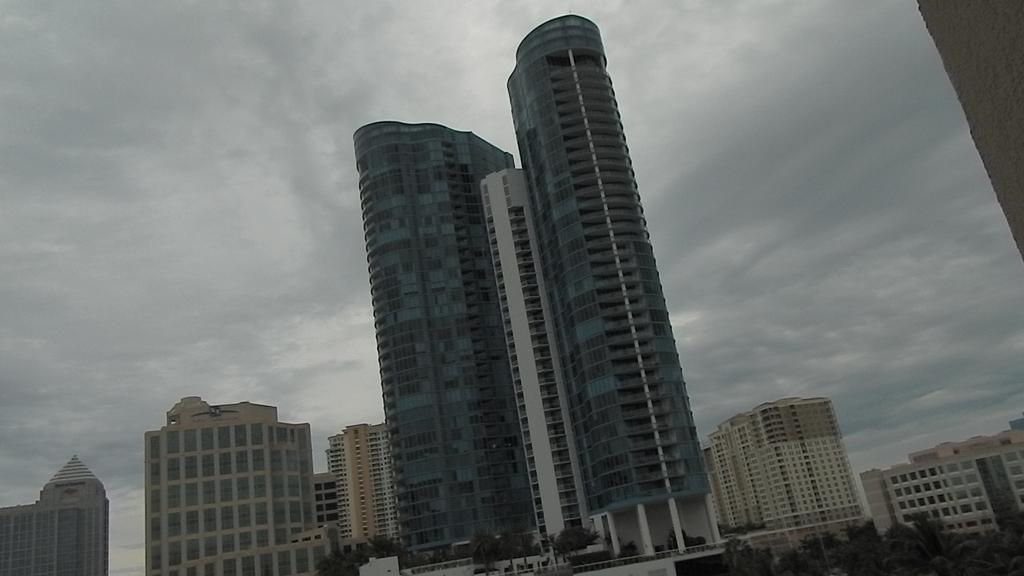What type of structures can be seen in the image? There are buildings in the image. What is located at the front of the image? There are trees at the front of the image. What can be seen in the background of the image? The sky is visible in the background of the image. What type of cream is being applied to the tub in the image? There is no tub or cream present in the image. What type of agreement is being signed by the people in the image? There are no people or agreement present in the image. 